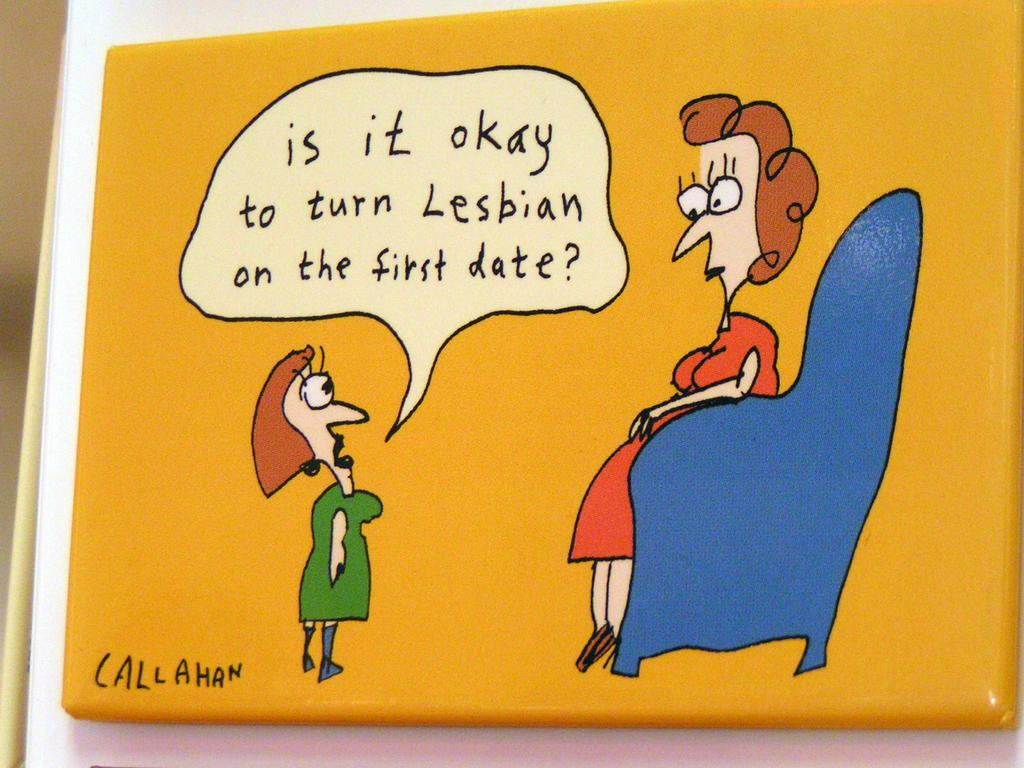What is the main object in the center of the image? There is a board in the center of the image. What is attached to the board? There is a banner on the board. What type of image is on the banner? The banner contains a cartoon picture. What else can be found on the banner? There is text on the banner. How does the board take flight in the image? The board does not take flight in the image; it is stationary and supports the banner. 